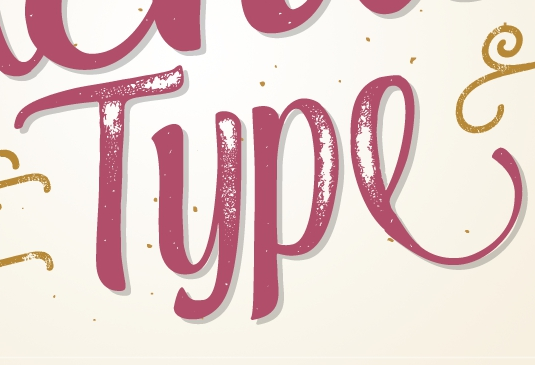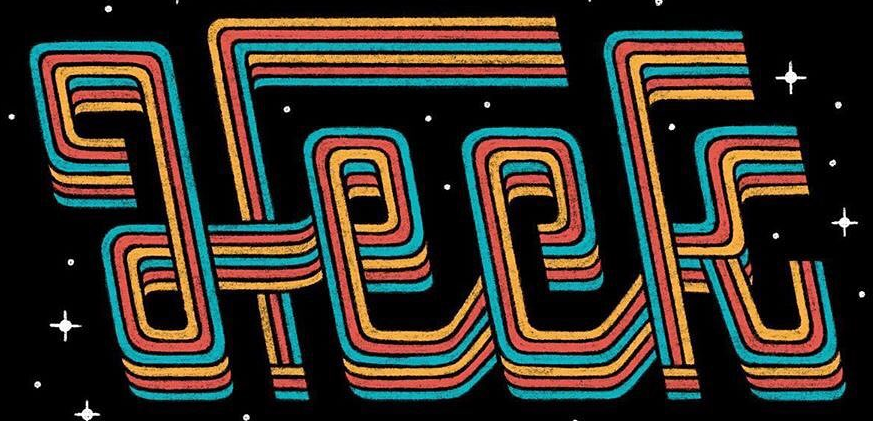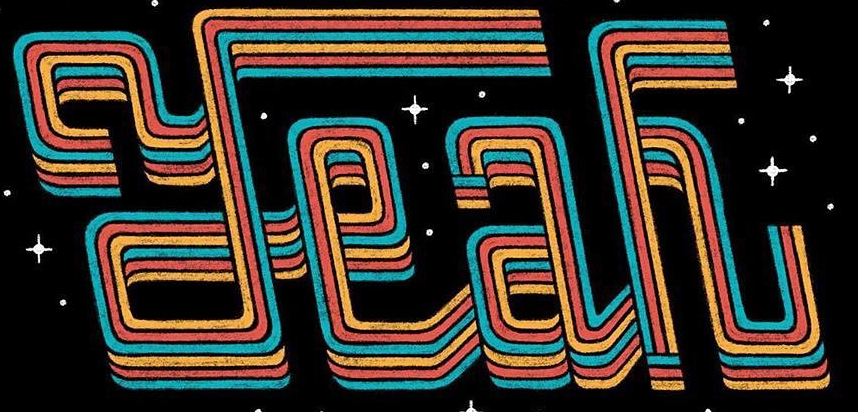What text appears in these images from left to right, separated by a semicolon? Type; Heck; Yeah 